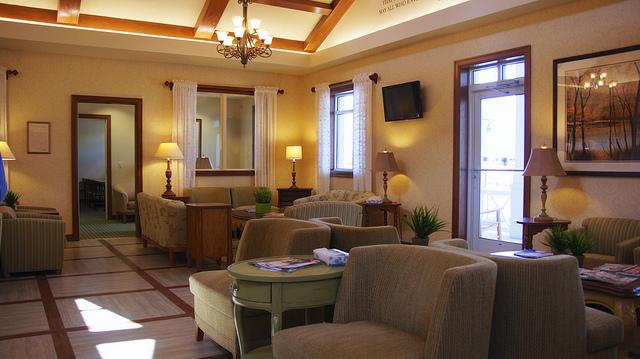What type room is this?

Choices:
A) bedroom
B) office
C) kitchen
D) lounge lounge 